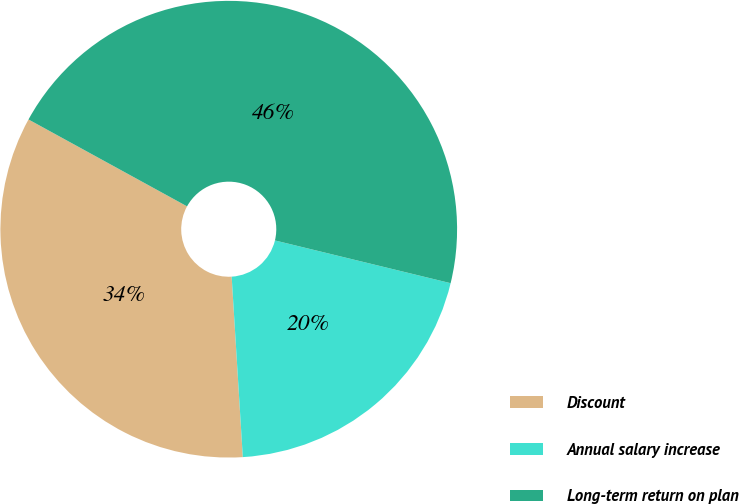<chart> <loc_0><loc_0><loc_500><loc_500><pie_chart><fcel>Discount<fcel>Annual salary increase<fcel>Long-term return on plan<nl><fcel>33.96%<fcel>20.22%<fcel>45.82%<nl></chart> 